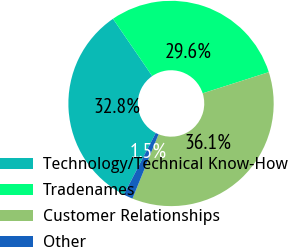Convert chart. <chart><loc_0><loc_0><loc_500><loc_500><pie_chart><fcel>Technology/Technical Know-How<fcel>Tradenames<fcel>Customer Relationships<fcel>Other<nl><fcel>32.84%<fcel>29.63%<fcel>36.06%<fcel>1.47%<nl></chart> 